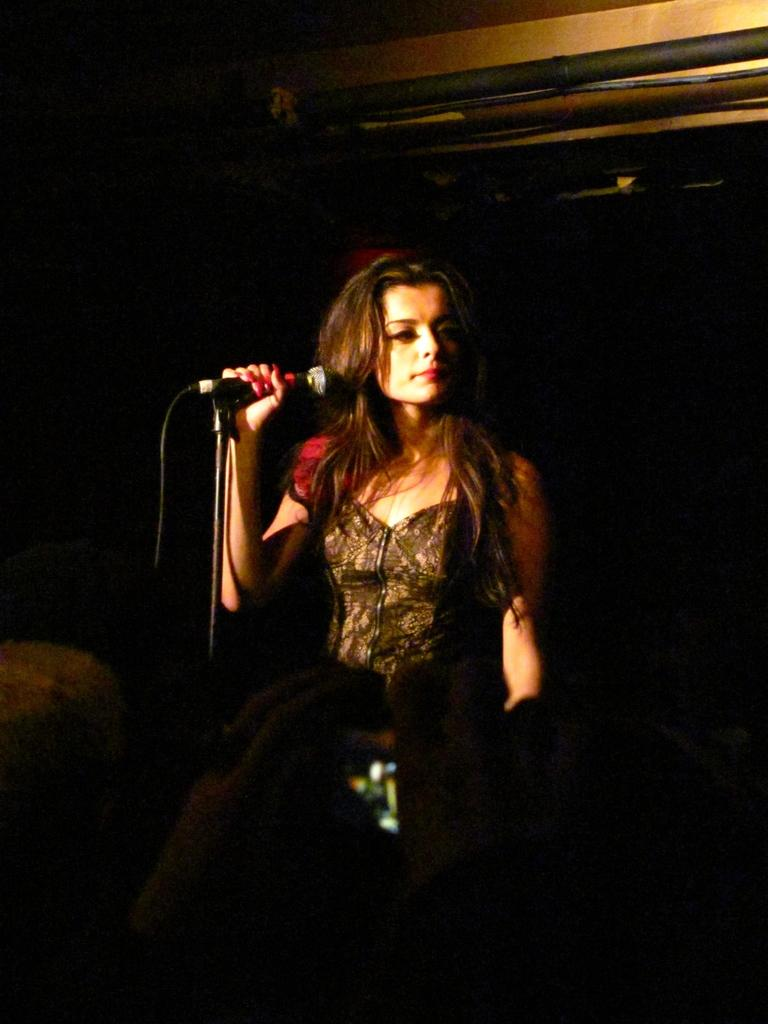Who is the main subject in the image? There is a woman in the image. What is the woman doing in the image? The woman is standing in the image. What object is the woman holding in her hand? The woman is holding a microphone in her hand. What type of library can be seen in the background of the image? There is no library present in the image; it features a woman standing and holding a microphone. How many bricks are visible in the image? There is no reference to bricks in the image, so it is not possible to determine how many bricks might be visible. 